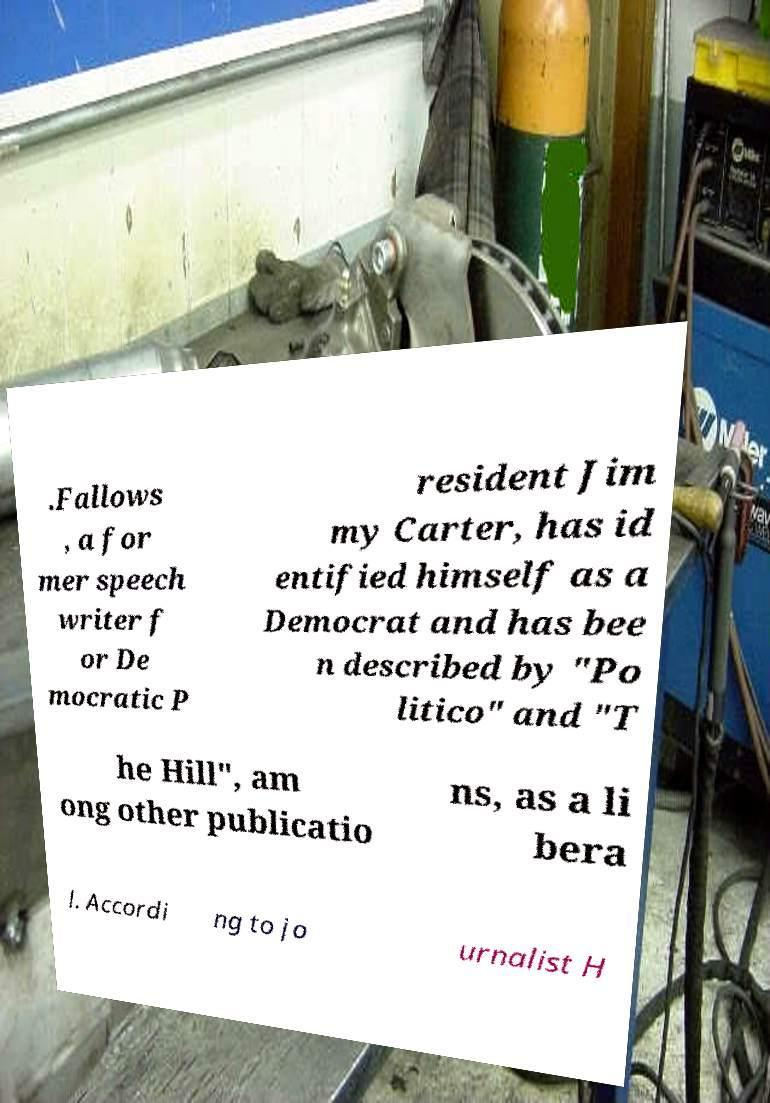Please read and relay the text visible in this image. What does it say? .Fallows , a for mer speech writer f or De mocratic P resident Jim my Carter, has id entified himself as a Democrat and has bee n described by "Po litico" and "T he Hill", am ong other publicatio ns, as a li bera l. Accordi ng to jo urnalist H 